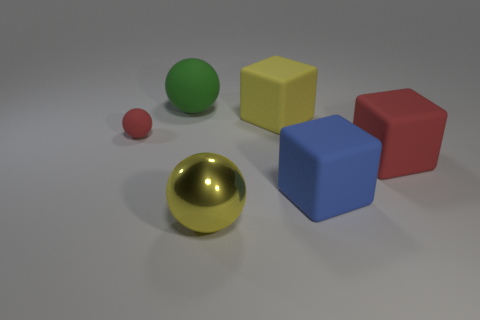Add 1 matte things. How many objects exist? 7 Add 1 blue things. How many blue things are left? 2 Add 5 red cubes. How many red cubes exist? 6 Subtract 0 gray cylinders. How many objects are left? 6 Subtract all large red cubes. Subtract all large yellow metal objects. How many objects are left? 4 